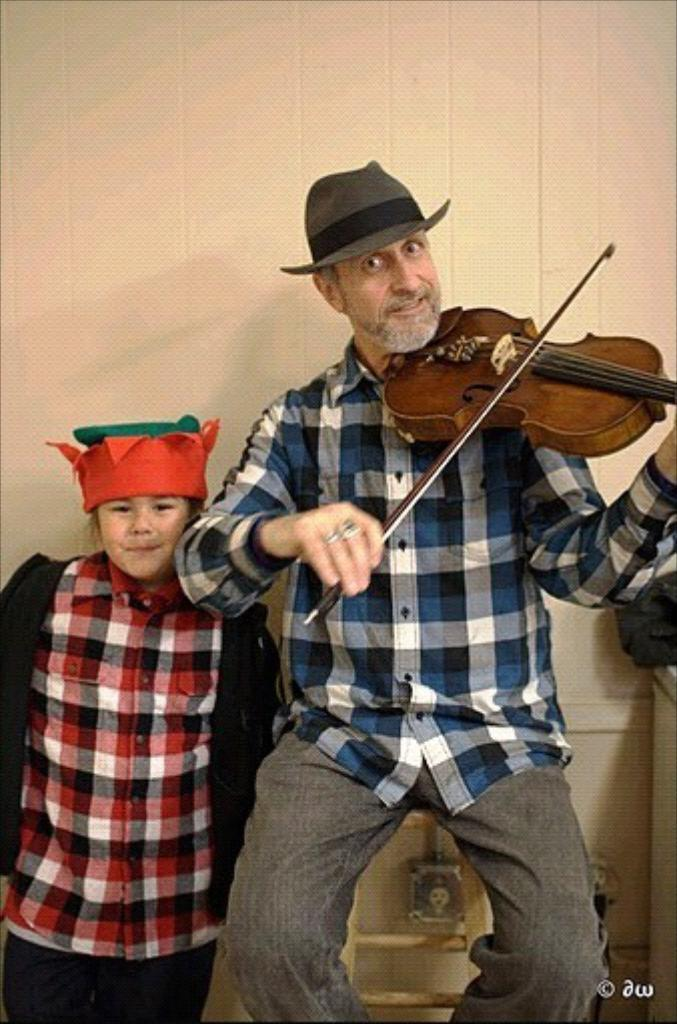How many people are present in the image? There are two people in the image, one standing and one sitting. What is the sitting person doing in the image? The sitting person is holding a musical instrument. What can be seen in the background of the image? There is a wall in the background of the image. What type of apples are growing on the stem in the image? There are no apples or stems present in the image. 